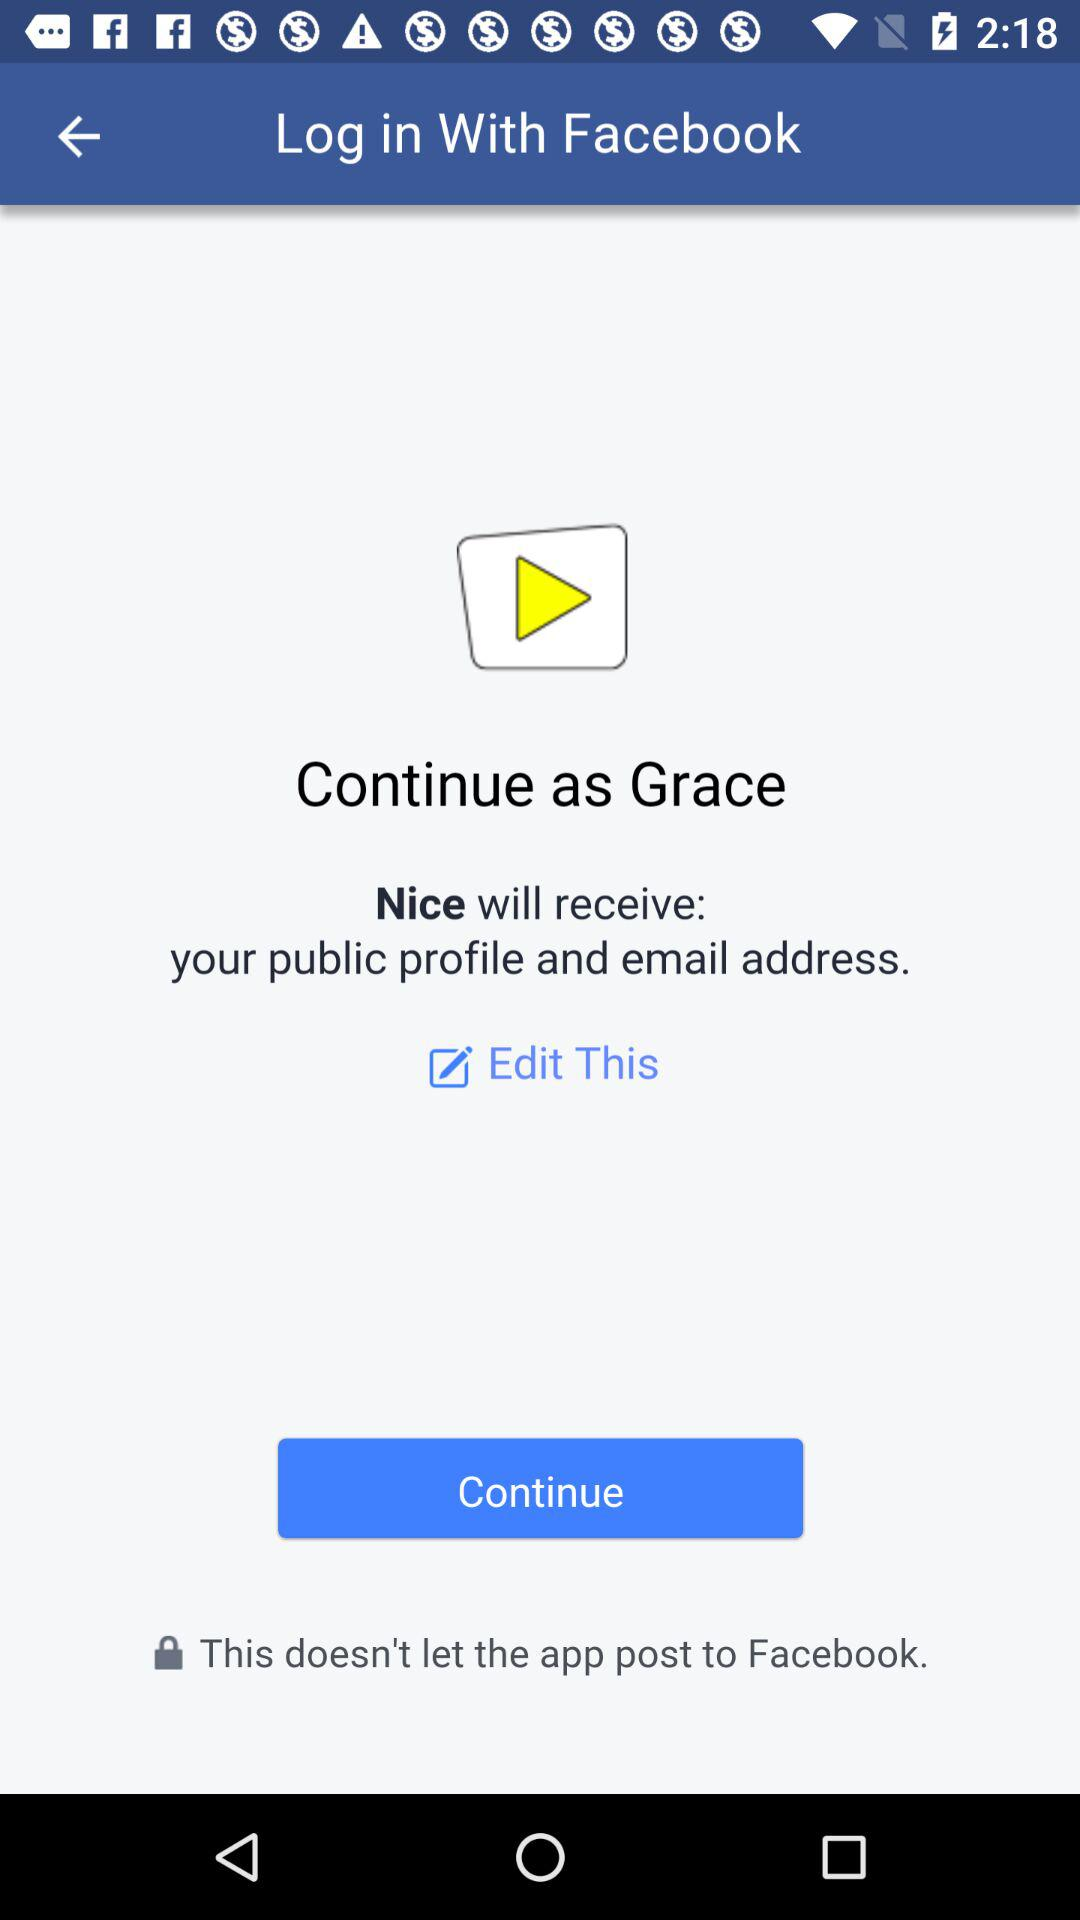What application is asking for permissions? The application is asking for permission is "Nice". 